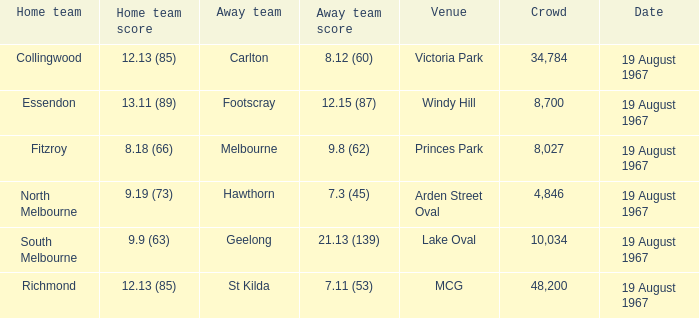What did the away team score when they were playing collingwood? 8.12 (60). 